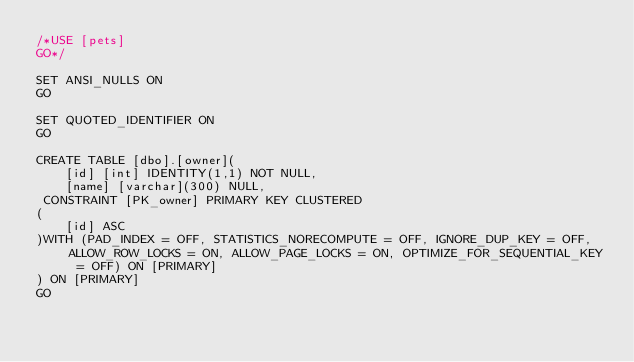<code> <loc_0><loc_0><loc_500><loc_500><_SQL_>/*USE [pets]
GO*/

SET ANSI_NULLS ON
GO

SET QUOTED_IDENTIFIER ON
GO

CREATE TABLE [dbo].[owner](
	[id] [int] IDENTITY(1,1) NOT NULL,
	[name] [varchar](300) NULL,
 CONSTRAINT [PK_owner] PRIMARY KEY CLUSTERED 
(
	[id] ASC
)WITH (PAD_INDEX = OFF, STATISTICS_NORECOMPUTE = OFF, IGNORE_DUP_KEY = OFF, ALLOW_ROW_LOCKS = ON, ALLOW_PAGE_LOCKS = ON, OPTIMIZE_FOR_SEQUENTIAL_KEY = OFF) ON [PRIMARY]
) ON [PRIMARY]
GO</code> 